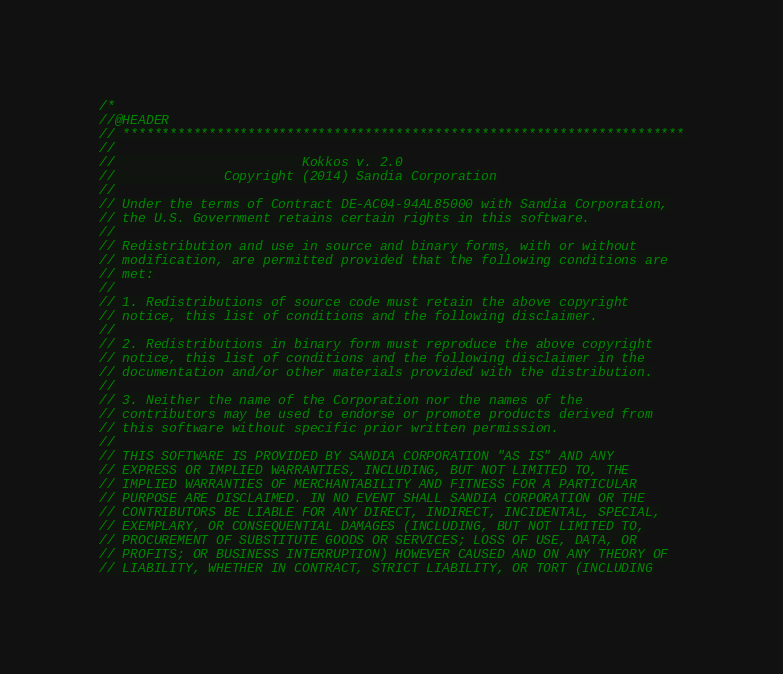Convert code to text. <code><loc_0><loc_0><loc_500><loc_500><_C++_>/*
//@HEADER
// ************************************************************************
//
//                        Kokkos v. 2.0
//              Copyright (2014) Sandia Corporation
//
// Under the terms of Contract DE-AC04-94AL85000 with Sandia Corporation,
// the U.S. Government retains certain rights in this software.
//
// Redistribution and use in source and binary forms, with or without
// modification, are permitted provided that the following conditions are
// met:
//
// 1. Redistributions of source code must retain the above copyright
// notice, this list of conditions and the following disclaimer.
//
// 2. Redistributions in binary form must reproduce the above copyright
// notice, this list of conditions and the following disclaimer in the
// documentation and/or other materials provided with the distribution.
//
// 3. Neither the name of the Corporation nor the names of the
// contributors may be used to endorse or promote products derived from
// this software without specific prior written permission.
//
// THIS SOFTWARE IS PROVIDED BY SANDIA CORPORATION "AS IS" AND ANY
// EXPRESS OR IMPLIED WARRANTIES, INCLUDING, BUT NOT LIMITED TO, THE
// IMPLIED WARRANTIES OF MERCHANTABILITY AND FITNESS FOR A PARTICULAR
// PURPOSE ARE DISCLAIMED. IN NO EVENT SHALL SANDIA CORPORATION OR THE
// CONTRIBUTORS BE LIABLE FOR ANY DIRECT, INDIRECT, INCIDENTAL, SPECIAL,
// EXEMPLARY, OR CONSEQUENTIAL DAMAGES (INCLUDING, BUT NOT LIMITED TO,
// PROCUREMENT OF SUBSTITUTE GOODS OR SERVICES; LOSS OF USE, DATA, OR
// PROFITS; OR BUSINESS INTERRUPTION) HOWEVER CAUSED AND ON ANY THEORY OF
// LIABILITY, WHETHER IN CONTRACT, STRICT LIABILITY, OR TORT (INCLUDING</code> 